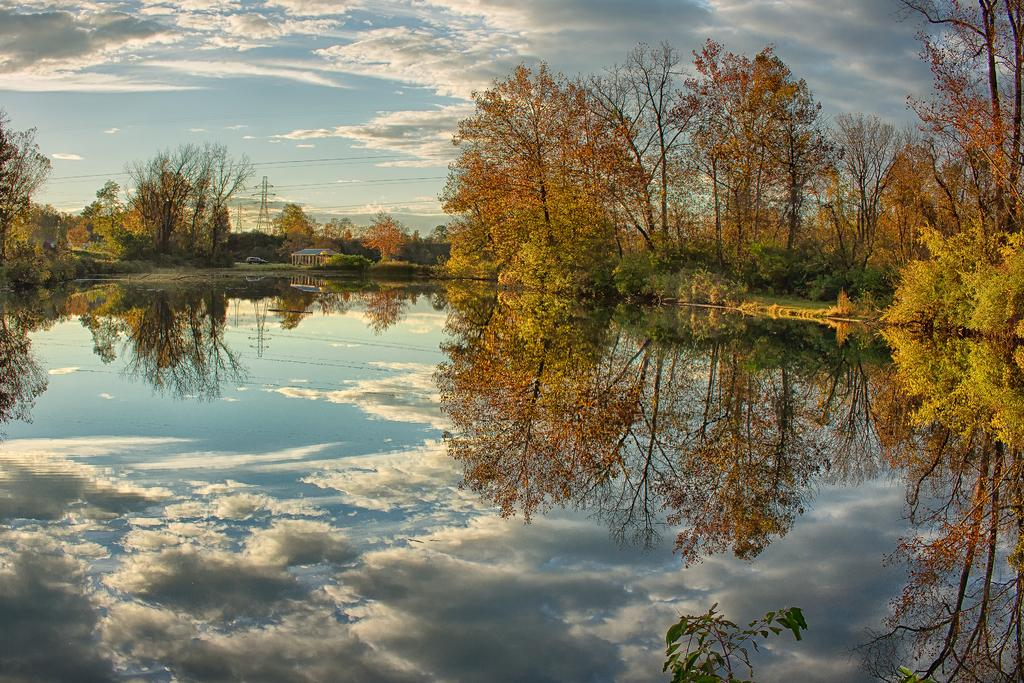What type of natural feature is present in the image? There is a lake in the image. What other objects or features can be seen in the image? There are trees, a tower, and wires visible in the image. What is visible in the background of the image? The sky is visible in the background of the image. What type of shoes can be seen hanging from the tower in the image? There are no shoes present in the image, and they are not hanging from the tower. 